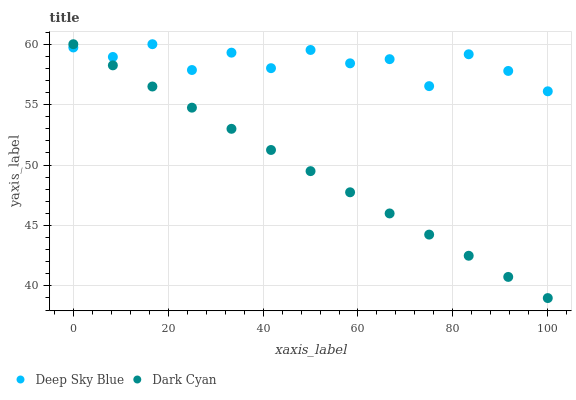Does Dark Cyan have the minimum area under the curve?
Answer yes or no. Yes. Does Deep Sky Blue have the maximum area under the curve?
Answer yes or no. Yes. Does Deep Sky Blue have the minimum area under the curve?
Answer yes or no. No. Is Dark Cyan the smoothest?
Answer yes or no. Yes. Is Deep Sky Blue the roughest?
Answer yes or no. Yes. Is Deep Sky Blue the smoothest?
Answer yes or no. No. Does Dark Cyan have the lowest value?
Answer yes or no. Yes. Does Deep Sky Blue have the lowest value?
Answer yes or no. No. Does Deep Sky Blue have the highest value?
Answer yes or no. Yes. Does Deep Sky Blue intersect Dark Cyan?
Answer yes or no. Yes. Is Deep Sky Blue less than Dark Cyan?
Answer yes or no. No. Is Deep Sky Blue greater than Dark Cyan?
Answer yes or no. No. 